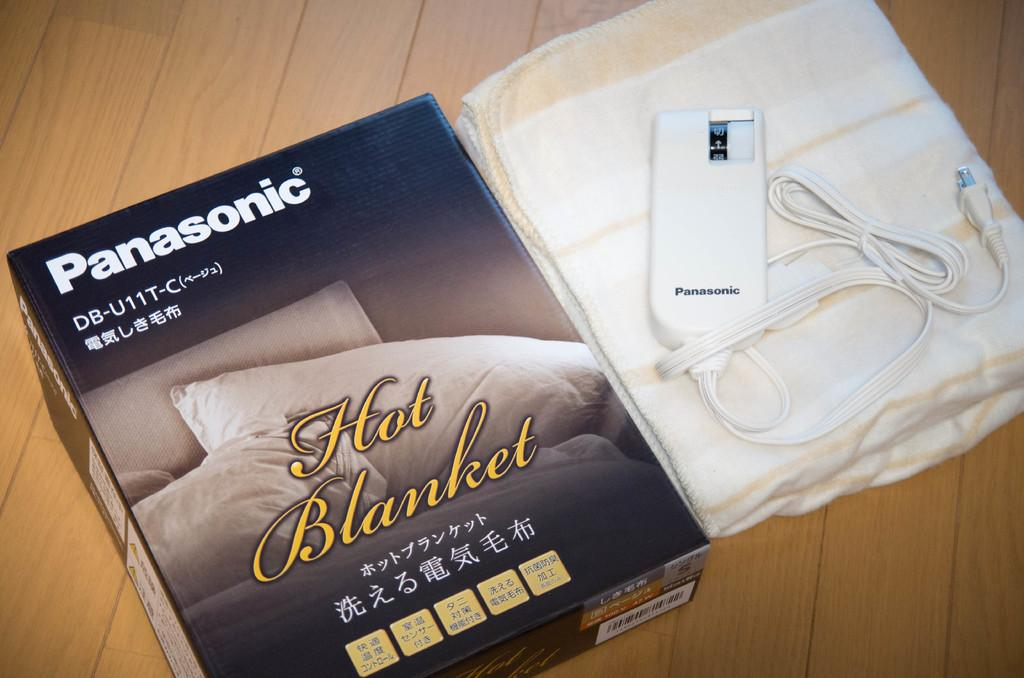What object can be seen in the image? There is a box in the image. What is located beside the box? There is a blanket beside the box. What is placed on top of the blanket? There is an electronic equipment on top of the blanket. Where is the electronic equipment positioned? The electronic equipment is placed on a table. What is the name of the silk sack in the image? There is no silk sack present in the image. 